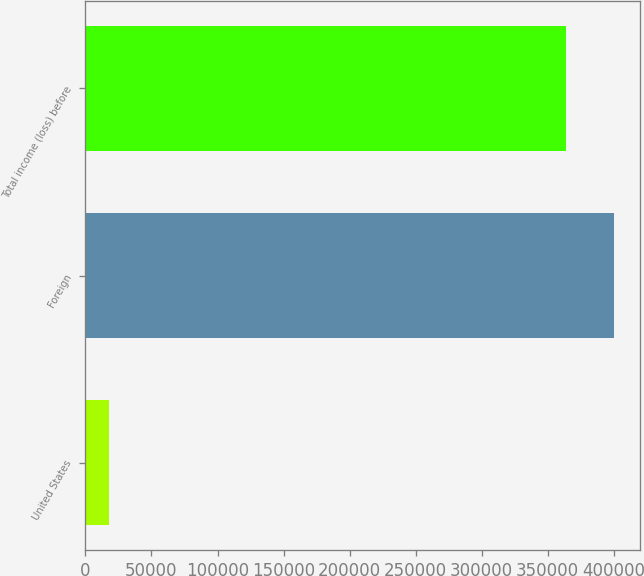Convert chart. <chart><loc_0><loc_0><loc_500><loc_500><bar_chart><fcel>United States<fcel>Foreign<fcel>Total income (loss) before<nl><fcel>18029<fcel>399897<fcel>363543<nl></chart> 